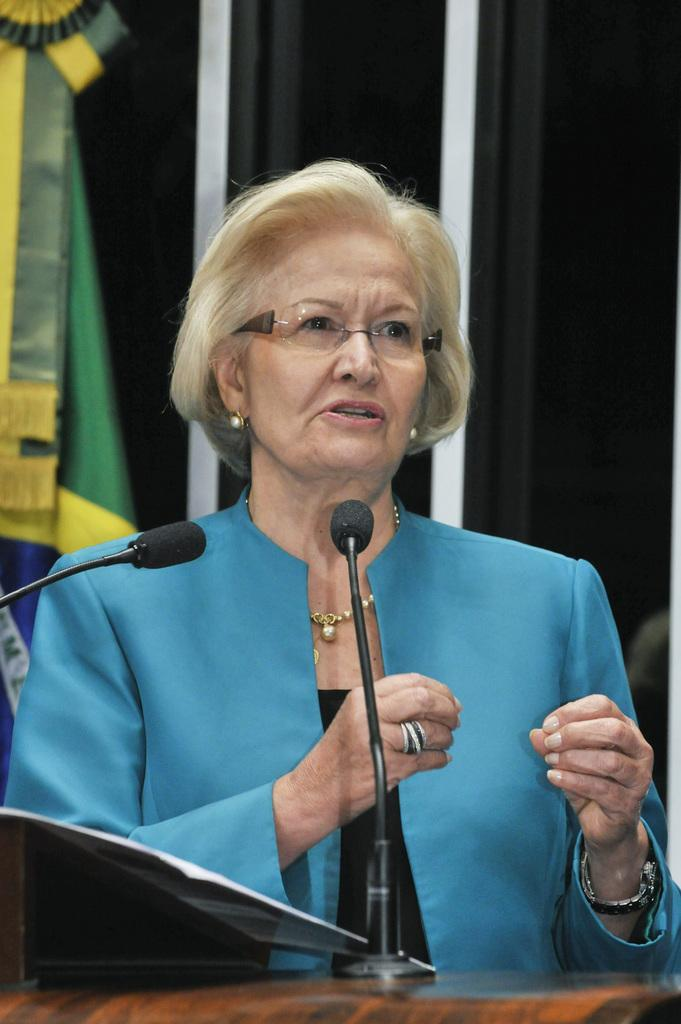Who is the main subject in the image? There is a woman in the image. What is the woman wearing? The woman is wearing a blue jacket. What is the woman doing in the image? The woman is standing behind a podium. What can be seen on the podium? There are miles and papers on the podium. What accessory is the woman wearing? The woman is wearing spectacles. What is located on the left side of the image? There is a flag on the left side of the image. What type of plantation can be seen in the background of the image? There is no plantation visible in the image. What is the woman using to open the bottle of cork in the image? There is no bottle or cork present in the image. 